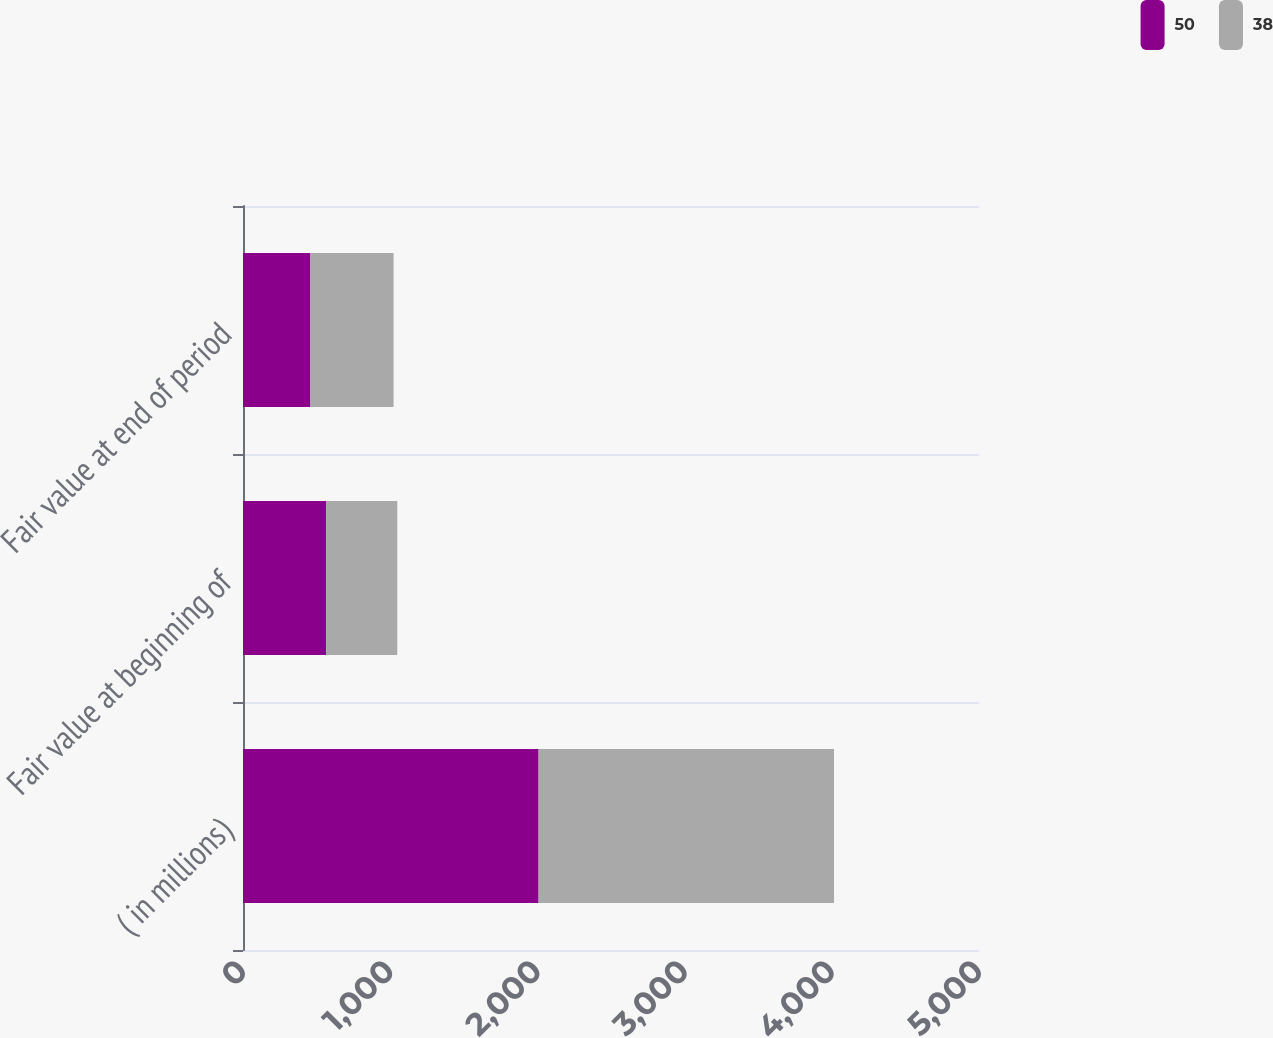<chart> <loc_0><loc_0><loc_500><loc_500><stacked_bar_chart><ecel><fcel>( in millions)<fcel>Fair value at beginning of<fcel>Fair value at end of period<nl><fcel>50<fcel>2008<fcel>565<fcel>458<nl><fcel>38<fcel>2007<fcel>483<fcel>565<nl></chart> 